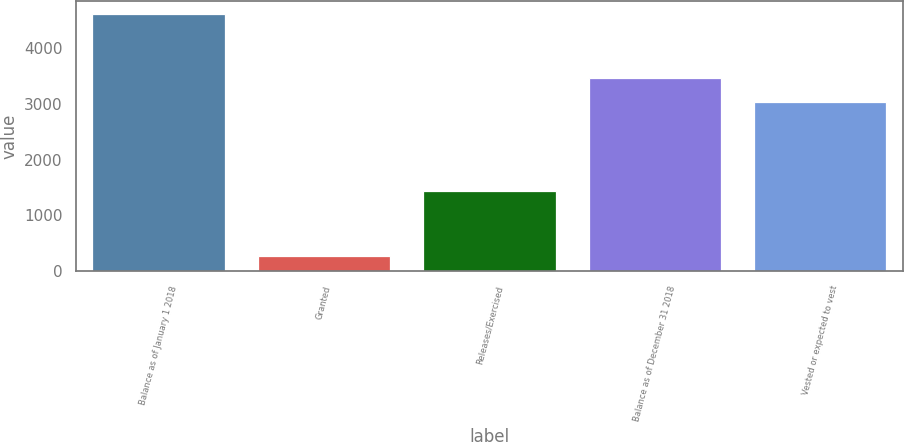<chart> <loc_0><loc_0><loc_500><loc_500><bar_chart><fcel>Balance as of January 1 2018<fcel>Granted<fcel>Releases/Exercised<fcel>Balance as of December 31 2018<fcel>Vested or expected to vest<nl><fcel>4604<fcel>272<fcel>1445<fcel>3465.2<fcel>3032<nl></chart> 